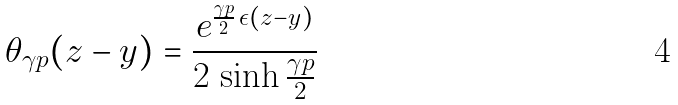Convert formula to latex. <formula><loc_0><loc_0><loc_500><loc_500>\theta _ { \gamma p } ( z - y ) = \frac { e ^ { \frac { \gamma p } { 2 } \, \epsilon ( z - y ) } } { 2 \, \sinh \frac { \gamma p } { 2 } }</formula> 